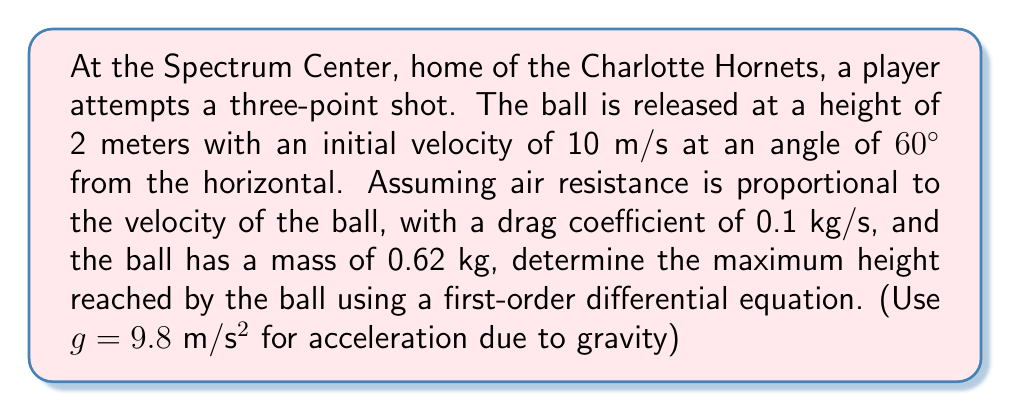Solve this math problem. Let's approach this step-by-step:

1) First, we need to set up our differential equation. The vertical motion of the ball is affected by gravity and air resistance. The equation of motion is:

   $$m\frac{d^2y}{dt^2} = -mg - k\frac{dy}{dt}$$

   where $m$ is the mass, $y$ is the vertical position, $g$ is the acceleration due to gravity, and $k$ is the drag coefficient.

2) We can simplify this by letting $v = \frac{dy}{dt}$ (velocity). Then our equation becomes:

   $$m\frac{dv}{dt} = -mg - kv$$

3) This is now a first-order differential equation in $v$. We can separate variables:

   $$\frac{dv}{-g - \frac{k}{m}v} = dt$$

4) Integrating both sides:

   $$-\frac{m}{k}\ln|-g - \frac{k}{m}v| = t + C$$

5) Using the initial conditions: At $t=0$, $v = v_0\sin\theta = 10\sin60° = 8.66$ m/s

   $$-\frac{m}{k}\ln|-g - \frac{k}{m}v_0\sin\theta| = C$$

6) Substituting back:

   $$-\frac{m}{k}\ln|-g - \frac{k}{m}v| = t - \frac{m}{k}\ln|-g - \frac{k}{m}v_0\sin\theta|$$

7) Solving for $v$:

   $$v = \frac{mg}{k} + (v_0\sin\theta + \frac{mg}{k})e^{-\frac{k}{m}t} - \frac{mg}{k}$$

8) To find the maximum height, we need to find when $v = 0$:

   $$0 = (v_0\sin\theta + \frac{mg}{k})e^{-\frac{k}{m}t} - \frac{mg}{k}$$

9) Solving for $t$:

   $$t_{max} = \frac{m}{k}\ln(1 + \frac{kv_0\sin\theta}{mg})$$

10) Now we can find the maximum height by integrating $v$ from $0$ to $t_{max}$:

    $$y_{max} = \int_0^{t_{max}} v dt = \frac{m}{k}(v_0\sin\theta + \frac{mg}{k})(1 - e^{-\frac{k}{m}t_{max}}) - \frac{mg}{k}t_{max} + 2$$

11) Substituting the values: $m = 0.62$ kg, $k = 0.1$ kg/s, $v_0 = 10$ m/s, $\theta = 60°$, $g = 9.8$ m/s²

12) Calculate $t_{max}$ and then $y_{max}$.
Answer: The maximum height reached by the ball is approximately 5.86 meters. 